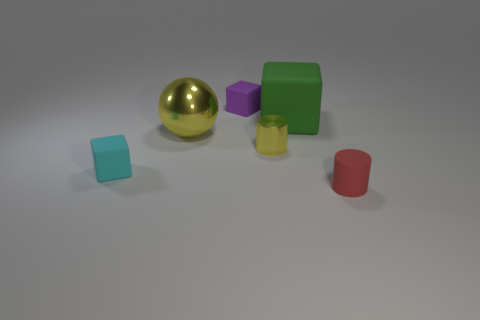Subtract all purple blocks. How many blocks are left? 2 Subtract all green blocks. How many blocks are left? 2 Add 1 large yellow metallic objects. How many objects exist? 7 Subtract all purple blocks. Subtract all brown spheres. How many blocks are left? 2 Subtract all blue blocks. How many gray spheres are left? 0 Subtract all cyan things. Subtract all small cubes. How many objects are left? 3 Add 4 cyan blocks. How many cyan blocks are left? 5 Add 6 cyan rubber cylinders. How many cyan rubber cylinders exist? 6 Subtract 0 gray cubes. How many objects are left? 6 Subtract all cylinders. How many objects are left? 4 